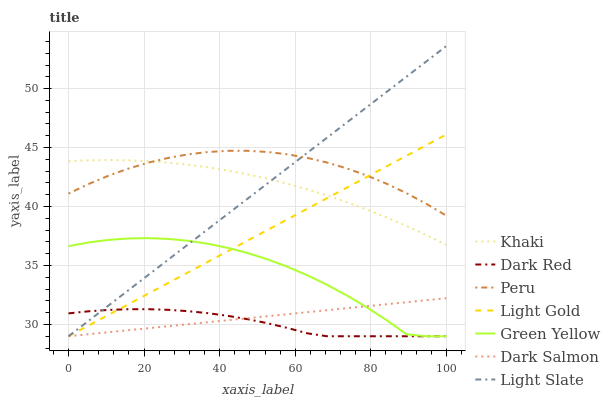Does Dark Red have the minimum area under the curve?
Answer yes or no. Yes. Does Peru have the maximum area under the curve?
Answer yes or no. Yes. Does Light Slate have the minimum area under the curve?
Answer yes or no. No. Does Light Slate have the maximum area under the curve?
Answer yes or no. No. Is Dark Salmon the smoothest?
Answer yes or no. Yes. Is Green Yellow the roughest?
Answer yes or no. Yes. Is Light Slate the smoothest?
Answer yes or no. No. Is Light Slate the roughest?
Answer yes or no. No. Does Peru have the lowest value?
Answer yes or no. No. Does Dark Red have the highest value?
Answer yes or no. No. Is Dark Red less than Peru?
Answer yes or no. Yes. Is Peru greater than Dark Salmon?
Answer yes or no. Yes. Does Dark Red intersect Peru?
Answer yes or no. No. 